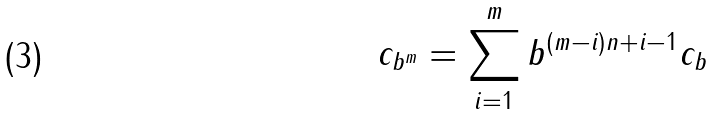<formula> <loc_0><loc_0><loc_500><loc_500>c _ { b ^ { m } } = \sum _ { i = 1 } ^ { m } b ^ { ( m - i ) n + i - 1 } c _ { b }</formula> 